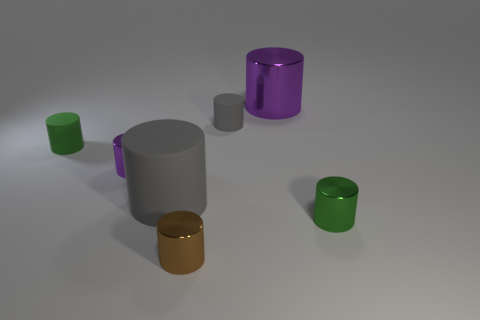What is the size of the rubber cylinder that is both on the right side of the tiny green matte thing and in front of the small gray thing?
Your response must be concise. Large. Is the shape of the tiny gray thing the same as the tiny brown shiny thing?
Keep it short and to the point. Yes. The small green object that is made of the same material as the large gray object is what shape?
Provide a succinct answer. Cylinder. What number of tiny things are rubber cylinders or cyan cylinders?
Your answer should be compact. 2. Is there a gray cylinder behind the tiny rubber cylinder that is right of the brown object?
Provide a short and direct response. No. Are any tiny yellow matte cubes visible?
Your response must be concise. No. What is the color of the large object behind the gray cylinder to the right of the brown shiny thing?
Offer a terse response. Purple. There is a small purple thing that is the same shape as the brown thing; what is its material?
Ensure brevity in your answer.  Metal. How many cylinders have the same size as the brown metallic thing?
Your response must be concise. 4. The green cylinder that is the same material as the tiny brown thing is what size?
Make the answer very short. Small. 